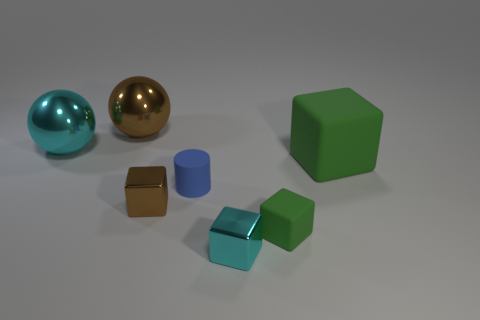How do the textures of the objects in the image differ? In the image, we can see a variety of textures that provide a visually rich environment. The small cyan cube and the golden sphere exhibit a smooth, metallic sheen, reflecting the environment with a polished finish. In contrast, the matte surfaces of the two large cubes, one green and one blue, as well as the two darker brown cubes, absorb more light, giving them a less reflective and flatter appearance. 